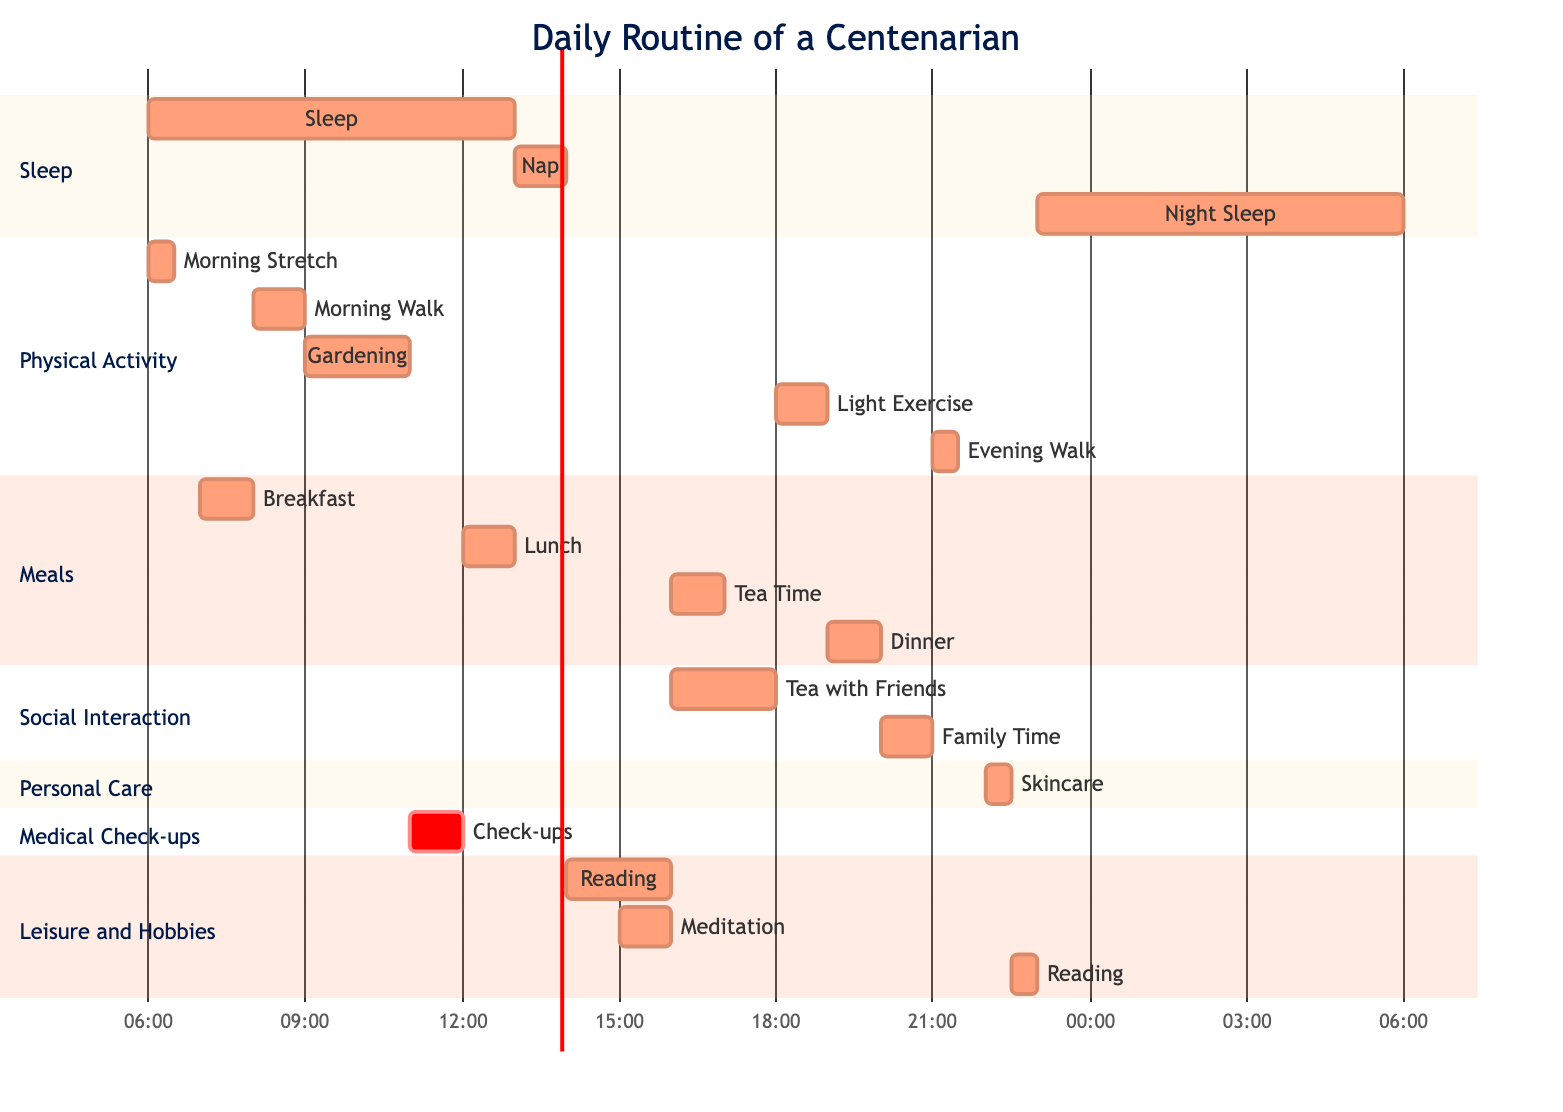What time does she have breakfast? According to the diagram, breakfast is scheduled for 07:00. This is specified under the 'Meals' section, where the time for each meal is clearly indicated.
Answer: 07:00 How long does she spend gardening? The diagram indicates that gardening takes 2 hours, as detailed in the 'Physical Activity' section. This activity starts at 09:00 and ends at 11:00.
Answer: 2h What is the total amount of time allocated for social interactions? To find this, I add the time for 'Tea with Friends' (2h) and 'Family Time' (1h). The total is 2h + 1h = 3h, as shown in the 'Social Interaction' section.
Answer: 3h When is her evening walk scheduled? The evening walk is noted in the diagram under the 'Physical Activity' section and is scheduled for 21:00. This is a direct data point representing when this activity occurs.
Answer: 21:00 What type of personal care does she practice before bed? The diagram indicates that she practices skincare, listed under the 'Personal Care' section and scheduled for 22:00. This is the only activity in that category.
Answer: Skincare How much time does she dedicate to leisure activities daily? The leisure activities include 'Reading' (2h + 0.5h) and 'Meditation' (1h). Adding these together gives 2h + 1h + 0.5h = 3.5h, summarizing her time for leisure pursuits.
Answer: 3.5h At what hour does she have her medical check-up? The check-up is scheduled for 11:00, which is explicitly listed in the 'Medical Check-ups' section of the diagram, making it a straightforward fact to identify.
Answer: 11:00 What is the first activity she does in the morning? The first activity listed in the 'Physical Activity' section is 'Morning Stretch', which starts at 06:00. This establishes it as her initial task after waking.
Answer: Morning Stretch 